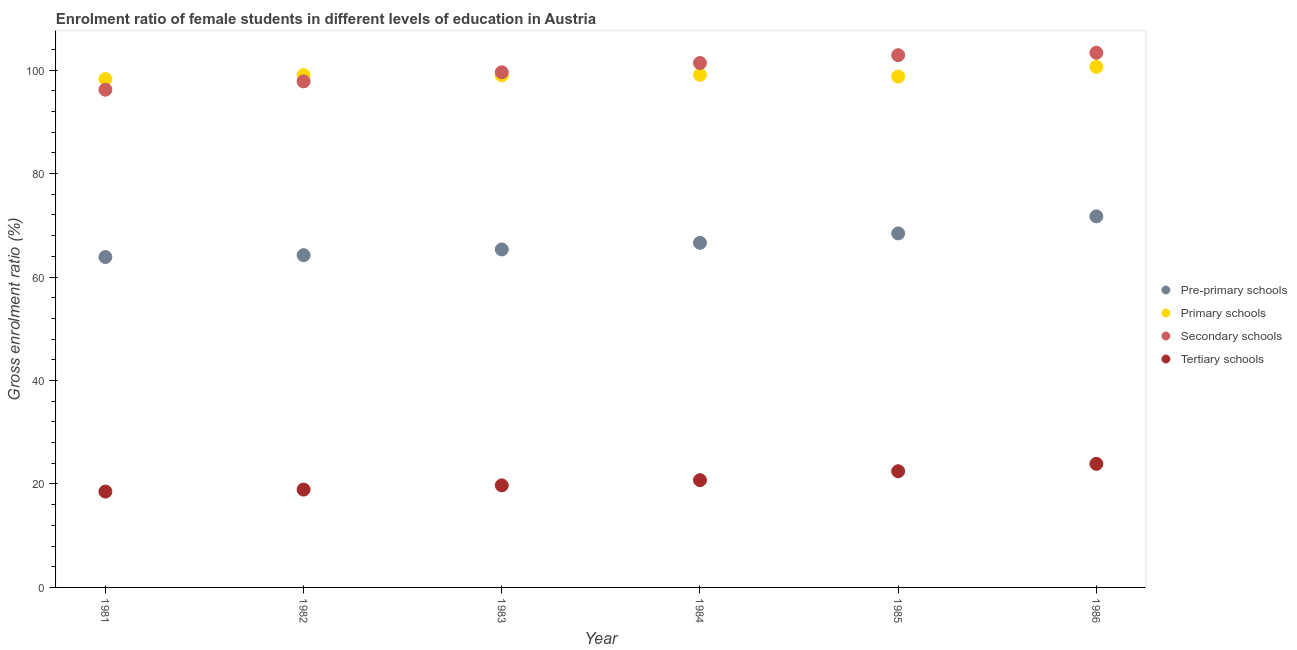Is the number of dotlines equal to the number of legend labels?
Keep it short and to the point. Yes. What is the gross enrolment ratio(male) in secondary schools in 1985?
Your answer should be very brief. 102.88. Across all years, what is the maximum gross enrolment ratio(male) in tertiary schools?
Offer a very short reply. 23.89. Across all years, what is the minimum gross enrolment ratio(male) in secondary schools?
Offer a very short reply. 96.21. What is the total gross enrolment ratio(male) in tertiary schools in the graph?
Make the answer very short. 124.24. What is the difference between the gross enrolment ratio(male) in pre-primary schools in 1985 and that in 1986?
Provide a short and direct response. -3.29. What is the difference between the gross enrolment ratio(male) in primary schools in 1985 and the gross enrolment ratio(male) in pre-primary schools in 1986?
Offer a very short reply. 27.02. What is the average gross enrolment ratio(male) in secondary schools per year?
Your response must be concise. 100.2. In the year 1986, what is the difference between the gross enrolment ratio(male) in tertiary schools and gross enrolment ratio(male) in primary schools?
Offer a very short reply. -76.74. In how many years, is the gross enrolment ratio(male) in pre-primary schools greater than 68 %?
Provide a short and direct response. 2. What is the ratio of the gross enrolment ratio(male) in tertiary schools in 1984 to that in 1985?
Offer a terse response. 0.92. Is the gross enrolment ratio(male) in pre-primary schools in 1982 less than that in 1983?
Your answer should be very brief. Yes. Is the difference between the gross enrolment ratio(male) in secondary schools in 1981 and 1983 greater than the difference between the gross enrolment ratio(male) in primary schools in 1981 and 1983?
Keep it short and to the point. No. What is the difference between the highest and the second highest gross enrolment ratio(male) in primary schools?
Provide a succinct answer. 1.54. What is the difference between the highest and the lowest gross enrolment ratio(male) in pre-primary schools?
Keep it short and to the point. 7.86. In how many years, is the gross enrolment ratio(male) in pre-primary schools greater than the average gross enrolment ratio(male) in pre-primary schools taken over all years?
Offer a terse response. 2. Is it the case that in every year, the sum of the gross enrolment ratio(male) in secondary schools and gross enrolment ratio(male) in primary schools is greater than the sum of gross enrolment ratio(male) in tertiary schools and gross enrolment ratio(male) in pre-primary schools?
Offer a terse response. No. Is it the case that in every year, the sum of the gross enrolment ratio(male) in pre-primary schools and gross enrolment ratio(male) in primary schools is greater than the gross enrolment ratio(male) in secondary schools?
Your answer should be compact. Yes. Is the gross enrolment ratio(male) in primary schools strictly greater than the gross enrolment ratio(male) in pre-primary schools over the years?
Provide a succinct answer. Yes. Does the graph contain any zero values?
Ensure brevity in your answer.  No. Does the graph contain grids?
Your response must be concise. No. How many legend labels are there?
Provide a succinct answer. 4. How are the legend labels stacked?
Offer a terse response. Vertical. What is the title of the graph?
Your answer should be very brief. Enrolment ratio of female students in different levels of education in Austria. What is the label or title of the X-axis?
Give a very brief answer. Year. What is the label or title of the Y-axis?
Your answer should be very brief. Gross enrolment ratio (%). What is the Gross enrolment ratio (%) in Pre-primary schools in 1981?
Keep it short and to the point. 63.86. What is the Gross enrolment ratio (%) in Primary schools in 1981?
Ensure brevity in your answer.  98.27. What is the Gross enrolment ratio (%) of Secondary schools in 1981?
Make the answer very short. 96.21. What is the Gross enrolment ratio (%) in Tertiary schools in 1981?
Your answer should be very brief. 18.53. What is the Gross enrolment ratio (%) in Pre-primary schools in 1982?
Keep it short and to the point. 64.22. What is the Gross enrolment ratio (%) in Primary schools in 1982?
Your response must be concise. 99.04. What is the Gross enrolment ratio (%) in Secondary schools in 1982?
Your answer should be compact. 97.81. What is the Gross enrolment ratio (%) of Tertiary schools in 1982?
Give a very brief answer. 18.91. What is the Gross enrolment ratio (%) in Pre-primary schools in 1983?
Your answer should be compact. 65.33. What is the Gross enrolment ratio (%) of Primary schools in 1983?
Offer a terse response. 98.97. What is the Gross enrolment ratio (%) of Secondary schools in 1983?
Make the answer very short. 99.58. What is the Gross enrolment ratio (%) in Tertiary schools in 1983?
Offer a very short reply. 19.73. What is the Gross enrolment ratio (%) in Pre-primary schools in 1984?
Offer a very short reply. 66.61. What is the Gross enrolment ratio (%) in Primary schools in 1984?
Offer a terse response. 99.09. What is the Gross enrolment ratio (%) of Secondary schools in 1984?
Provide a succinct answer. 101.37. What is the Gross enrolment ratio (%) of Tertiary schools in 1984?
Your response must be concise. 20.73. What is the Gross enrolment ratio (%) in Pre-primary schools in 1985?
Offer a very short reply. 68.43. What is the Gross enrolment ratio (%) of Primary schools in 1985?
Keep it short and to the point. 98.75. What is the Gross enrolment ratio (%) of Secondary schools in 1985?
Provide a short and direct response. 102.88. What is the Gross enrolment ratio (%) of Tertiary schools in 1985?
Ensure brevity in your answer.  22.46. What is the Gross enrolment ratio (%) in Pre-primary schools in 1986?
Make the answer very short. 71.72. What is the Gross enrolment ratio (%) of Primary schools in 1986?
Ensure brevity in your answer.  100.63. What is the Gross enrolment ratio (%) in Secondary schools in 1986?
Keep it short and to the point. 103.35. What is the Gross enrolment ratio (%) in Tertiary schools in 1986?
Keep it short and to the point. 23.89. Across all years, what is the maximum Gross enrolment ratio (%) of Pre-primary schools?
Ensure brevity in your answer.  71.72. Across all years, what is the maximum Gross enrolment ratio (%) of Primary schools?
Give a very brief answer. 100.63. Across all years, what is the maximum Gross enrolment ratio (%) in Secondary schools?
Make the answer very short. 103.35. Across all years, what is the maximum Gross enrolment ratio (%) of Tertiary schools?
Keep it short and to the point. 23.89. Across all years, what is the minimum Gross enrolment ratio (%) in Pre-primary schools?
Your answer should be very brief. 63.86. Across all years, what is the minimum Gross enrolment ratio (%) in Primary schools?
Offer a very short reply. 98.27. Across all years, what is the minimum Gross enrolment ratio (%) of Secondary schools?
Make the answer very short. 96.21. Across all years, what is the minimum Gross enrolment ratio (%) in Tertiary schools?
Offer a very short reply. 18.53. What is the total Gross enrolment ratio (%) in Pre-primary schools in the graph?
Give a very brief answer. 400.18. What is the total Gross enrolment ratio (%) in Primary schools in the graph?
Your response must be concise. 594.75. What is the total Gross enrolment ratio (%) in Secondary schools in the graph?
Offer a very short reply. 601.2. What is the total Gross enrolment ratio (%) of Tertiary schools in the graph?
Offer a very short reply. 124.24. What is the difference between the Gross enrolment ratio (%) in Pre-primary schools in 1981 and that in 1982?
Offer a terse response. -0.36. What is the difference between the Gross enrolment ratio (%) of Primary schools in 1981 and that in 1982?
Make the answer very short. -0.77. What is the difference between the Gross enrolment ratio (%) of Secondary schools in 1981 and that in 1982?
Give a very brief answer. -1.6. What is the difference between the Gross enrolment ratio (%) of Tertiary schools in 1981 and that in 1982?
Provide a short and direct response. -0.38. What is the difference between the Gross enrolment ratio (%) of Pre-primary schools in 1981 and that in 1983?
Ensure brevity in your answer.  -1.47. What is the difference between the Gross enrolment ratio (%) in Primary schools in 1981 and that in 1983?
Provide a succinct answer. -0.7. What is the difference between the Gross enrolment ratio (%) in Secondary schools in 1981 and that in 1983?
Give a very brief answer. -3.37. What is the difference between the Gross enrolment ratio (%) of Tertiary schools in 1981 and that in 1983?
Offer a very short reply. -1.2. What is the difference between the Gross enrolment ratio (%) in Pre-primary schools in 1981 and that in 1984?
Provide a succinct answer. -2.75. What is the difference between the Gross enrolment ratio (%) in Primary schools in 1981 and that in 1984?
Offer a terse response. -0.82. What is the difference between the Gross enrolment ratio (%) of Secondary schools in 1981 and that in 1984?
Give a very brief answer. -5.15. What is the difference between the Gross enrolment ratio (%) of Tertiary schools in 1981 and that in 1984?
Your response must be concise. -2.21. What is the difference between the Gross enrolment ratio (%) in Pre-primary schools in 1981 and that in 1985?
Offer a terse response. -4.57. What is the difference between the Gross enrolment ratio (%) in Primary schools in 1981 and that in 1985?
Provide a short and direct response. -0.48. What is the difference between the Gross enrolment ratio (%) in Secondary schools in 1981 and that in 1985?
Keep it short and to the point. -6.67. What is the difference between the Gross enrolment ratio (%) in Tertiary schools in 1981 and that in 1985?
Offer a terse response. -3.93. What is the difference between the Gross enrolment ratio (%) of Pre-primary schools in 1981 and that in 1986?
Keep it short and to the point. -7.86. What is the difference between the Gross enrolment ratio (%) in Primary schools in 1981 and that in 1986?
Give a very brief answer. -2.36. What is the difference between the Gross enrolment ratio (%) of Secondary schools in 1981 and that in 1986?
Your response must be concise. -7.13. What is the difference between the Gross enrolment ratio (%) in Tertiary schools in 1981 and that in 1986?
Ensure brevity in your answer.  -5.36. What is the difference between the Gross enrolment ratio (%) in Pre-primary schools in 1982 and that in 1983?
Ensure brevity in your answer.  -1.11. What is the difference between the Gross enrolment ratio (%) of Primary schools in 1982 and that in 1983?
Provide a short and direct response. 0.07. What is the difference between the Gross enrolment ratio (%) of Secondary schools in 1982 and that in 1983?
Provide a short and direct response. -1.76. What is the difference between the Gross enrolment ratio (%) in Tertiary schools in 1982 and that in 1983?
Your response must be concise. -0.82. What is the difference between the Gross enrolment ratio (%) of Pre-primary schools in 1982 and that in 1984?
Keep it short and to the point. -2.39. What is the difference between the Gross enrolment ratio (%) in Primary schools in 1982 and that in 1984?
Provide a short and direct response. -0.05. What is the difference between the Gross enrolment ratio (%) in Secondary schools in 1982 and that in 1984?
Make the answer very short. -3.55. What is the difference between the Gross enrolment ratio (%) in Tertiary schools in 1982 and that in 1984?
Your answer should be very brief. -1.82. What is the difference between the Gross enrolment ratio (%) in Pre-primary schools in 1982 and that in 1985?
Keep it short and to the point. -4.21. What is the difference between the Gross enrolment ratio (%) of Primary schools in 1982 and that in 1985?
Provide a short and direct response. 0.3. What is the difference between the Gross enrolment ratio (%) in Secondary schools in 1982 and that in 1985?
Offer a terse response. -5.07. What is the difference between the Gross enrolment ratio (%) in Tertiary schools in 1982 and that in 1985?
Offer a terse response. -3.55. What is the difference between the Gross enrolment ratio (%) in Pre-primary schools in 1982 and that in 1986?
Your response must be concise. -7.5. What is the difference between the Gross enrolment ratio (%) in Primary schools in 1982 and that in 1986?
Make the answer very short. -1.59. What is the difference between the Gross enrolment ratio (%) in Secondary schools in 1982 and that in 1986?
Provide a short and direct response. -5.53. What is the difference between the Gross enrolment ratio (%) of Tertiary schools in 1982 and that in 1986?
Offer a very short reply. -4.98. What is the difference between the Gross enrolment ratio (%) in Pre-primary schools in 1983 and that in 1984?
Your response must be concise. -1.28. What is the difference between the Gross enrolment ratio (%) in Primary schools in 1983 and that in 1984?
Provide a short and direct response. -0.12. What is the difference between the Gross enrolment ratio (%) of Secondary schools in 1983 and that in 1984?
Keep it short and to the point. -1.79. What is the difference between the Gross enrolment ratio (%) of Tertiary schools in 1983 and that in 1984?
Offer a terse response. -1.01. What is the difference between the Gross enrolment ratio (%) of Pre-primary schools in 1983 and that in 1985?
Ensure brevity in your answer.  -3.1. What is the difference between the Gross enrolment ratio (%) of Primary schools in 1983 and that in 1985?
Your response must be concise. 0.22. What is the difference between the Gross enrolment ratio (%) in Secondary schools in 1983 and that in 1985?
Your response must be concise. -3.3. What is the difference between the Gross enrolment ratio (%) in Tertiary schools in 1983 and that in 1985?
Offer a very short reply. -2.73. What is the difference between the Gross enrolment ratio (%) of Pre-primary schools in 1983 and that in 1986?
Your answer should be compact. -6.39. What is the difference between the Gross enrolment ratio (%) of Primary schools in 1983 and that in 1986?
Your answer should be compact. -1.66. What is the difference between the Gross enrolment ratio (%) in Secondary schools in 1983 and that in 1986?
Offer a terse response. -3.77. What is the difference between the Gross enrolment ratio (%) of Tertiary schools in 1983 and that in 1986?
Give a very brief answer. -4.16. What is the difference between the Gross enrolment ratio (%) in Pre-primary schools in 1984 and that in 1985?
Your response must be concise. -1.82. What is the difference between the Gross enrolment ratio (%) of Primary schools in 1984 and that in 1985?
Your response must be concise. 0.34. What is the difference between the Gross enrolment ratio (%) of Secondary schools in 1984 and that in 1985?
Offer a terse response. -1.52. What is the difference between the Gross enrolment ratio (%) of Tertiary schools in 1984 and that in 1985?
Keep it short and to the point. -1.72. What is the difference between the Gross enrolment ratio (%) of Pre-primary schools in 1984 and that in 1986?
Ensure brevity in your answer.  -5.11. What is the difference between the Gross enrolment ratio (%) of Primary schools in 1984 and that in 1986?
Make the answer very short. -1.54. What is the difference between the Gross enrolment ratio (%) of Secondary schools in 1984 and that in 1986?
Make the answer very short. -1.98. What is the difference between the Gross enrolment ratio (%) in Tertiary schools in 1984 and that in 1986?
Your answer should be very brief. -3.15. What is the difference between the Gross enrolment ratio (%) in Pre-primary schools in 1985 and that in 1986?
Give a very brief answer. -3.29. What is the difference between the Gross enrolment ratio (%) of Primary schools in 1985 and that in 1986?
Provide a succinct answer. -1.88. What is the difference between the Gross enrolment ratio (%) of Secondary schools in 1985 and that in 1986?
Offer a terse response. -0.46. What is the difference between the Gross enrolment ratio (%) of Tertiary schools in 1985 and that in 1986?
Your answer should be compact. -1.43. What is the difference between the Gross enrolment ratio (%) of Pre-primary schools in 1981 and the Gross enrolment ratio (%) of Primary schools in 1982?
Your response must be concise. -35.18. What is the difference between the Gross enrolment ratio (%) of Pre-primary schools in 1981 and the Gross enrolment ratio (%) of Secondary schools in 1982?
Your answer should be very brief. -33.95. What is the difference between the Gross enrolment ratio (%) of Pre-primary schools in 1981 and the Gross enrolment ratio (%) of Tertiary schools in 1982?
Provide a succinct answer. 44.95. What is the difference between the Gross enrolment ratio (%) in Primary schools in 1981 and the Gross enrolment ratio (%) in Secondary schools in 1982?
Offer a terse response. 0.46. What is the difference between the Gross enrolment ratio (%) of Primary schools in 1981 and the Gross enrolment ratio (%) of Tertiary schools in 1982?
Offer a terse response. 79.36. What is the difference between the Gross enrolment ratio (%) in Secondary schools in 1981 and the Gross enrolment ratio (%) in Tertiary schools in 1982?
Provide a short and direct response. 77.3. What is the difference between the Gross enrolment ratio (%) of Pre-primary schools in 1981 and the Gross enrolment ratio (%) of Primary schools in 1983?
Your response must be concise. -35.11. What is the difference between the Gross enrolment ratio (%) of Pre-primary schools in 1981 and the Gross enrolment ratio (%) of Secondary schools in 1983?
Give a very brief answer. -35.71. What is the difference between the Gross enrolment ratio (%) in Pre-primary schools in 1981 and the Gross enrolment ratio (%) in Tertiary schools in 1983?
Provide a succinct answer. 44.14. What is the difference between the Gross enrolment ratio (%) in Primary schools in 1981 and the Gross enrolment ratio (%) in Secondary schools in 1983?
Provide a short and direct response. -1.31. What is the difference between the Gross enrolment ratio (%) of Primary schools in 1981 and the Gross enrolment ratio (%) of Tertiary schools in 1983?
Keep it short and to the point. 78.54. What is the difference between the Gross enrolment ratio (%) of Secondary schools in 1981 and the Gross enrolment ratio (%) of Tertiary schools in 1983?
Offer a terse response. 76.49. What is the difference between the Gross enrolment ratio (%) of Pre-primary schools in 1981 and the Gross enrolment ratio (%) of Primary schools in 1984?
Provide a short and direct response. -35.22. What is the difference between the Gross enrolment ratio (%) of Pre-primary schools in 1981 and the Gross enrolment ratio (%) of Secondary schools in 1984?
Ensure brevity in your answer.  -37.5. What is the difference between the Gross enrolment ratio (%) of Pre-primary schools in 1981 and the Gross enrolment ratio (%) of Tertiary schools in 1984?
Your response must be concise. 43.13. What is the difference between the Gross enrolment ratio (%) in Primary schools in 1981 and the Gross enrolment ratio (%) in Secondary schools in 1984?
Make the answer very short. -3.1. What is the difference between the Gross enrolment ratio (%) in Primary schools in 1981 and the Gross enrolment ratio (%) in Tertiary schools in 1984?
Your answer should be very brief. 77.54. What is the difference between the Gross enrolment ratio (%) in Secondary schools in 1981 and the Gross enrolment ratio (%) in Tertiary schools in 1984?
Keep it short and to the point. 75.48. What is the difference between the Gross enrolment ratio (%) of Pre-primary schools in 1981 and the Gross enrolment ratio (%) of Primary schools in 1985?
Make the answer very short. -34.88. What is the difference between the Gross enrolment ratio (%) of Pre-primary schools in 1981 and the Gross enrolment ratio (%) of Secondary schools in 1985?
Provide a short and direct response. -39.02. What is the difference between the Gross enrolment ratio (%) in Pre-primary schools in 1981 and the Gross enrolment ratio (%) in Tertiary schools in 1985?
Give a very brief answer. 41.41. What is the difference between the Gross enrolment ratio (%) in Primary schools in 1981 and the Gross enrolment ratio (%) in Secondary schools in 1985?
Your answer should be very brief. -4.61. What is the difference between the Gross enrolment ratio (%) in Primary schools in 1981 and the Gross enrolment ratio (%) in Tertiary schools in 1985?
Offer a terse response. 75.81. What is the difference between the Gross enrolment ratio (%) in Secondary schools in 1981 and the Gross enrolment ratio (%) in Tertiary schools in 1985?
Offer a very short reply. 73.76. What is the difference between the Gross enrolment ratio (%) in Pre-primary schools in 1981 and the Gross enrolment ratio (%) in Primary schools in 1986?
Offer a very short reply. -36.76. What is the difference between the Gross enrolment ratio (%) of Pre-primary schools in 1981 and the Gross enrolment ratio (%) of Secondary schools in 1986?
Give a very brief answer. -39.48. What is the difference between the Gross enrolment ratio (%) of Pre-primary schools in 1981 and the Gross enrolment ratio (%) of Tertiary schools in 1986?
Give a very brief answer. 39.98. What is the difference between the Gross enrolment ratio (%) of Primary schools in 1981 and the Gross enrolment ratio (%) of Secondary schools in 1986?
Ensure brevity in your answer.  -5.08. What is the difference between the Gross enrolment ratio (%) in Primary schools in 1981 and the Gross enrolment ratio (%) in Tertiary schools in 1986?
Offer a terse response. 74.38. What is the difference between the Gross enrolment ratio (%) in Secondary schools in 1981 and the Gross enrolment ratio (%) in Tertiary schools in 1986?
Offer a very short reply. 72.32. What is the difference between the Gross enrolment ratio (%) in Pre-primary schools in 1982 and the Gross enrolment ratio (%) in Primary schools in 1983?
Your answer should be compact. -34.75. What is the difference between the Gross enrolment ratio (%) in Pre-primary schools in 1982 and the Gross enrolment ratio (%) in Secondary schools in 1983?
Your answer should be compact. -35.36. What is the difference between the Gross enrolment ratio (%) of Pre-primary schools in 1982 and the Gross enrolment ratio (%) of Tertiary schools in 1983?
Provide a succinct answer. 44.5. What is the difference between the Gross enrolment ratio (%) in Primary schools in 1982 and the Gross enrolment ratio (%) in Secondary schools in 1983?
Ensure brevity in your answer.  -0.54. What is the difference between the Gross enrolment ratio (%) in Primary schools in 1982 and the Gross enrolment ratio (%) in Tertiary schools in 1983?
Provide a short and direct response. 79.32. What is the difference between the Gross enrolment ratio (%) of Secondary schools in 1982 and the Gross enrolment ratio (%) of Tertiary schools in 1983?
Your answer should be compact. 78.09. What is the difference between the Gross enrolment ratio (%) of Pre-primary schools in 1982 and the Gross enrolment ratio (%) of Primary schools in 1984?
Offer a terse response. -34.86. What is the difference between the Gross enrolment ratio (%) in Pre-primary schools in 1982 and the Gross enrolment ratio (%) in Secondary schools in 1984?
Offer a very short reply. -37.14. What is the difference between the Gross enrolment ratio (%) of Pre-primary schools in 1982 and the Gross enrolment ratio (%) of Tertiary schools in 1984?
Your answer should be compact. 43.49. What is the difference between the Gross enrolment ratio (%) of Primary schools in 1982 and the Gross enrolment ratio (%) of Secondary schools in 1984?
Keep it short and to the point. -2.32. What is the difference between the Gross enrolment ratio (%) of Primary schools in 1982 and the Gross enrolment ratio (%) of Tertiary schools in 1984?
Make the answer very short. 78.31. What is the difference between the Gross enrolment ratio (%) in Secondary schools in 1982 and the Gross enrolment ratio (%) in Tertiary schools in 1984?
Offer a very short reply. 77.08. What is the difference between the Gross enrolment ratio (%) of Pre-primary schools in 1982 and the Gross enrolment ratio (%) of Primary schools in 1985?
Your answer should be very brief. -34.52. What is the difference between the Gross enrolment ratio (%) in Pre-primary schools in 1982 and the Gross enrolment ratio (%) in Secondary schools in 1985?
Offer a very short reply. -38.66. What is the difference between the Gross enrolment ratio (%) in Pre-primary schools in 1982 and the Gross enrolment ratio (%) in Tertiary schools in 1985?
Give a very brief answer. 41.77. What is the difference between the Gross enrolment ratio (%) of Primary schools in 1982 and the Gross enrolment ratio (%) of Secondary schools in 1985?
Offer a very short reply. -3.84. What is the difference between the Gross enrolment ratio (%) in Primary schools in 1982 and the Gross enrolment ratio (%) in Tertiary schools in 1985?
Ensure brevity in your answer.  76.58. What is the difference between the Gross enrolment ratio (%) in Secondary schools in 1982 and the Gross enrolment ratio (%) in Tertiary schools in 1985?
Your answer should be compact. 75.36. What is the difference between the Gross enrolment ratio (%) in Pre-primary schools in 1982 and the Gross enrolment ratio (%) in Primary schools in 1986?
Ensure brevity in your answer.  -36.41. What is the difference between the Gross enrolment ratio (%) in Pre-primary schools in 1982 and the Gross enrolment ratio (%) in Secondary schools in 1986?
Offer a terse response. -39.12. What is the difference between the Gross enrolment ratio (%) of Pre-primary schools in 1982 and the Gross enrolment ratio (%) of Tertiary schools in 1986?
Keep it short and to the point. 40.33. What is the difference between the Gross enrolment ratio (%) of Primary schools in 1982 and the Gross enrolment ratio (%) of Secondary schools in 1986?
Offer a terse response. -4.3. What is the difference between the Gross enrolment ratio (%) of Primary schools in 1982 and the Gross enrolment ratio (%) of Tertiary schools in 1986?
Your response must be concise. 75.15. What is the difference between the Gross enrolment ratio (%) of Secondary schools in 1982 and the Gross enrolment ratio (%) of Tertiary schools in 1986?
Your response must be concise. 73.93. What is the difference between the Gross enrolment ratio (%) of Pre-primary schools in 1983 and the Gross enrolment ratio (%) of Primary schools in 1984?
Offer a terse response. -33.76. What is the difference between the Gross enrolment ratio (%) of Pre-primary schools in 1983 and the Gross enrolment ratio (%) of Secondary schools in 1984?
Give a very brief answer. -36.04. What is the difference between the Gross enrolment ratio (%) in Pre-primary schools in 1983 and the Gross enrolment ratio (%) in Tertiary schools in 1984?
Offer a very short reply. 44.6. What is the difference between the Gross enrolment ratio (%) in Primary schools in 1983 and the Gross enrolment ratio (%) in Secondary schools in 1984?
Provide a succinct answer. -2.4. What is the difference between the Gross enrolment ratio (%) in Primary schools in 1983 and the Gross enrolment ratio (%) in Tertiary schools in 1984?
Your answer should be very brief. 78.24. What is the difference between the Gross enrolment ratio (%) in Secondary schools in 1983 and the Gross enrolment ratio (%) in Tertiary schools in 1984?
Give a very brief answer. 78.85. What is the difference between the Gross enrolment ratio (%) in Pre-primary schools in 1983 and the Gross enrolment ratio (%) in Primary schools in 1985?
Keep it short and to the point. -33.42. What is the difference between the Gross enrolment ratio (%) of Pre-primary schools in 1983 and the Gross enrolment ratio (%) of Secondary schools in 1985?
Give a very brief answer. -37.55. What is the difference between the Gross enrolment ratio (%) in Pre-primary schools in 1983 and the Gross enrolment ratio (%) in Tertiary schools in 1985?
Make the answer very short. 42.87. What is the difference between the Gross enrolment ratio (%) of Primary schools in 1983 and the Gross enrolment ratio (%) of Secondary schools in 1985?
Your answer should be compact. -3.91. What is the difference between the Gross enrolment ratio (%) of Primary schools in 1983 and the Gross enrolment ratio (%) of Tertiary schools in 1985?
Your response must be concise. 76.51. What is the difference between the Gross enrolment ratio (%) of Secondary schools in 1983 and the Gross enrolment ratio (%) of Tertiary schools in 1985?
Offer a very short reply. 77.12. What is the difference between the Gross enrolment ratio (%) of Pre-primary schools in 1983 and the Gross enrolment ratio (%) of Primary schools in 1986?
Offer a terse response. -35.3. What is the difference between the Gross enrolment ratio (%) of Pre-primary schools in 1983 and the Gross enrolment ratio (%) of Secondary schools in 1986?
Your answer should be compact. -38.02. What is the difference between the Gross enrolment ratio (%) in Pre-primary schools in 1983 and the Gross enrolment ratio (%) in Tertiary schools in 1986?
Give a very brief answer. 41.44. What is the difference between the Gross enrolment ratio (%) of Primary schools in 1983 and the Gross enrolment ratio (%) of Secondary schools in 1986?
Ensure brevity in your answer.  -4.38. What is the difference between the Gross enrolment ratio (%) in Primary schools in 1983 and the Gross enrolment ratio (%) in Tertiary schools in 1986?
Offer a very short reply. 75.08. What is the difference between the Gross enrolment ratio (%) in Secondary schools in 1983 and the Gross enrolment ratio (%) in Tertiary schools in 1986?
Offer a terse response. 75.69. What is the difference between the Gross enrolment ratio (%) in Pre-primary schools in 1984 and the Gross enrolment ratio (%) in Primary schools in 1985?
Keep it short and to the point. -32.13. What is the difference between the Gross enrolment ratio (%) of Pre-primary schools in 1984 and the Gross enrolment ratio (%) of Secondary schools in 1985?
Ensure brevity in your answer.  -36.27. What is the difference between the Gross enrolment ratio (%) in Pre-primary schools in 1984 and the Gross enrolment ratio (%) in Tertiary schools in 1985?
Your answer should be very brief. 44.16. What is the difference between the Gross enrolment ratio (%) in Primary schools in 1984 and the Gross enrolment ratio (%) in Secondary schools in 1985?
Your response must be concise. -3.79. What is the difference between the Gross enrolment ratio (%) in Primary schools in 1984 and the Gross enrolment ratio (%) in Tertiary schools in 1985?
Keep it short and to the point. 76.63. What is the difference between the Gross enrolment ratio (%) in Secondary schools in 1984 and the Gross enrolment ratio (%) in Tertiary schools in 1985?
Give a very brief answer. 78.91. What is the difference between the Gross enrolment ratio (%) in Pre-primary schools in 1984 and the Gross enrolment ratio (%) in Primary schools in 1986?
Make the answer very short. -34.01. What is the difference between the Gross enrolment ratio (%) in Pre-primary schools in 1984 and the Gross enrolment ratio (%) in Secondary schools in 1986?
Give a very brief answer. -36.73. What is the difference between the Gross enrolment ratio (%) of Pre-primary schools in 1984 and the Gross enrolment ratio (%) of Tertiary schools in 1986?
Ensure brevity in your answer.  42.73. What is the difference between the Gross enrolment ratio (%) in Primary schools in 1984 and the Gross enrolment ratio (%) in Secondary schools in 1986?
Ensure brevity in your answer.  -4.26. What is the difference between the Gross enrolment ratio (%) of Primary schools in 1984 and the Gross enrolment ratio (%) of Tertiary schools in 1986?
Your answer should be very brief. 75.2. What is the difference between the Gross enrolment ratio (%) in Secondary schools in 1984 and the Gross enrolment ratio (%) in Tertiary schools in 1986?
Give a very brief answer. 77.48. What is the difference between the Gross enrolment ratio (%) of Pre-primary schools in 1985 and the Gross enrolment ratio (%) of Primary schools in 1986?
Offer a very short reply. -32.2. What is the difference between the Gross enrolment ratio (%) in Pre-primary schools in 1985 and the Gross enrolment ratio (%) in Secondary schools in 1986?
Keep it short and to the point. -34.92. What is the difference between the Gross enrolment ratio (%) of Pre-primary schools in 1985 and the Gross enrolment ratio (%) of Tertiary schools in 1986?
Give a very brief answer. 44.54. What is the difference between the Gross enrolment ratio (%) of Primary schools in 1985 and the Gross enrolment ratio (%) of Secondary schools in 1986?
Make the answer very short. -4.6. What is the difference between the Gross enrolment ratio (%) in Primary schools in 1985 and the Gross enrolment ratio (%) in Tertiary schools in 1986?
Provide a short and direct response. 74.86. What is the difference between the Gross enrolment ratio (%) of Secondary schools in 1985 and the Gross enrolment ratio (%) of Tertiary schools in 1986?
Provide a succinct answer. 78.99. What is the average Gross enrolment ratio (%) in Pre-primary schools per year?
Your response must be concise. 66.7. What is the average Gross enrolment ratio (%) in Primary schools per year?
Give a very brief answer. 99.12. What is the average Gross enrolment ratio (%) of Secondary schools per year?
Give a very brief answer. 100.2. What is the average Gross enrolment ratio (%) of Tertiary schools per year?
Give a very brief answer. 20.71. In the year 1981, what is the difference between the Gross enrolment ratio (%) of Pre-primary schools and Gross enrolment ratio (%) of Primary schools?
Your answer should be very brief. -34.41. In the year 1981, what is the difference between the Gross enrolment ratio (%) of Pre-primary schools and Gross enrolment ratio (%) of Secondary schools?
Your response must be concise. -32.35. In the year 1981, what is the difference between the Gross enrolment ratio (%) of Pre-primary schools and Gross enrolment ratio (%) of Tertiary schools?
Your answer should be compact. 45.34. In the year 1981, what is the difference between the Gross enrolment ratio (%) of Primary schools and Gross enrolment ratio (%) of Secondary schools?
Keep it short and to the point. 2.06. In the year 1981, what is the difference between the Gross enrolment ratio (%) of Primary schools and Gross enrolment ratio (%) of Tertiary schools?
Your answer should be compact. 79.75. In the year 1981, what is the difference between the Gross enrolment ratio (%) in Secondary schools and Gross enrolment ratio (%) in Tertiary schools?
Your answer should be compact. 77.69. In the year 1982, what is the difference between the Gross enrolment ratio (%) of Pre-primary schools and Gross enrolment ratio (%) of Primary schools?
Give a very brief answer. -34.82. In the year 1982, what is the difference between the Gross enrolment ratio (%) in Pre-primary schools and Gross enrolment ratio (%) in Secondary schools?
Keep it short and to the point. -33.59. In the year 1982, what is the difference between the Gross enrolment ratio (%) in Pre-primary schools and Gross enrolment ratio (%) in Tertiary schools?
Give a very brief answer. 45.31. In the year 1982, what is the difference between the Gross enrolment ratio (%) in Primary schools and Gross enrolment ratio (%) in Secondary schools?
Ensure brevity in your answer.  1.23. In the year 1982, what is the difference between the Gross enrolment ratio (%) in Primary schools and Gross enrolment ratio (%) in Tertiary schools?
Provide a short and direct response. 80.13. In the year 1982, what is the difference between the Gross enrolment ratio (%) of Secondary schools and Gross enrolment ratio (%) of Tertiary schools?
Make the answer very short. 78.9. In the year 1983, what is the difference between the Gross enrolment ratio (%) of Pre-primary schools and Gross enrolment ratio (%) of Primary schools?
Make the answer very short. -33.64. In the year 1983, what is the difference between the Gross enrolment ratio (%) of Pre-primary schools and Gross enrolment ratio (%) of Secondary schools?
Provide a short and direct response. -34.25. In the year 1983, what is the difference between the Gross enrolment ratio (%) in Pre-primary schools and Gross enrolment ratio (%) in Tertiary schools?
Make the answer very short. 45.6. In the year 1983, what is the difference between the Gross enrolment ratio (%) of Primary schools and Gross enrolment ratio (%) of Secondary schools?
Your response must be concise. -0.61. In the year 1983, what is the difference between the Gross enrolment ratio (%) of Primary schools and Gross enrolment ratio (%) of Tertiary schools?
Provide a succinct answer. 79.24. In the year 1983, what is the difference between the Gross enrolment ratio (%) of Secondary schools and Gross enrolment ratio (%) of Tertiary schools?
Ensure brevity in your answer.  79.85. In the year 1984, what is the difference between the Gross enrolment ratio (%) in Pre-primary schools and Gross enrolment ratio (%) in Primary schools?
Give a very brief answer. -32.47. In the year 1984, what is the difference between the Gross enrolment ratio (%) of Pre-primary schools and Gross enrolment ratio (%) of Secondary schools?
Your answer should be compact. -34.75. In the year 1984, what is the difference between the Gross enrolment ratio (%) in Pre-primary schools and Gross enrolment ratio (%) in Tertiary schools?
Your answer should be very brief. 45.88. In the year 1984, what is the difference between the Gross enrolment ratio (%) in Primary schools and Gross enrolment ratio (%) in Secondary schools?
Your answer should be compact. -2.28. In the year 1984, what is the difference between the Gross enrolment ratio (%) of Primary schools and Gross enrolment ratio (%) of Tertiary schools?
Your answer should be compact. 78.35. In the year 1984, what is the difference between the Gross enrolment ratio (%) in Secondary schools and Gross enrolment ratio (%) in Tertiary schools?
Offer a terse response. 80.63. In the year 1985, what is the difference between the Gross enrolment ratio (%) in Pre-primary schools and Gross enrolment ratio (%) in Primary schools?
Ensure brevity in your answer.  -30.32. In the year 1985, what is the difference between the Gross enrolment ratio (%) of Pre-primary schools and Gross enrolment ratio (%) of Secondary schools?
Ensure brevity in your answer.  -34.45. In the year 1985, what is the difference between the Gross enrolment ratio (%) in Pre-primary schools and Gross enrolment ratio (%) in Tertiary schools?
Your answer should be compact. 45.97. In the year 1985, what is the difference between the Gross enrolment ratio (%) in Primary schools and Gross enrolment ratio (%) in Secondary schools?
Make the answer very short. -4.14. In the year 1985, what is the difference between the Gross enrolment ratio (%) in Primary schools and Gross enrolment ratio (%) in Tertiary schools?
Your answer should be very brief. 76.29. In the year 1985, what is the difference between the Gross enrolment ratio (%) in Secondary schools and Gross enrolment ratio (%) in Tertiary schools?
Your answer should be compact. 80.42. In the year 1986, what is the difference between the Gross enrolment ratio (%) of Pre-primary schools and Gross enrolment ratio (%) of Primary schools?
Your answer should be compact. -28.9. In the year 1986, what is the difference between the Gross enrolment ratio (%) in Pre-primary schools and Gross enrolment ratio (%) in Secondary schools?
Provide a succinct answer. -31.62. In the year 1986, what is the difference between the Gross enrolment ratio (%) of Pre-primary schools and Gross enrolment ratio (%) of Tertiary schools?
Offer a terse response. 47.84. In the year 1986, what is the difference between the Gross enrolment ratio (%) in Primary schools and Gross enrolment ratio (%) in Secondary schools?
Ensure brevity in your answer.  -2.72. In the year 1986, what is the difference between the Gross enrolment ratio (%) of Primary schools and Gross enrolment ratio (%) of Tertiary schools?
Offer a very short reply. 76.74. In the year 1986, what is the difference between the Gross enrolment ratio (%) in Secondary schools and Gross enrolment ratio (%) in Tertiary schools?
Give a very brief answer. 79.46. What is the ratio of the Gross enrolment ratio (%) in Primary schools in 1981 to that in 1982?
Keep it short and to the point. 0.99. What is the ratio of the Gross enrolment ratio (%) in Secondary schools in 1981 to that in 1982?
Provide a succinct answer. 0.98. What is the ratio of the Gross enrolment ratio (%) of Tertiary schools in 1981 to that in 1982?
Offer a terse response. 0.98. What is the ratio of the Gross enrolment ratio (%) in Pre-primary schools in 1981 to that in 1983?
Offer a very short reply. 0.98. What is the ratio of the Gross enrolment ratio (%) of Primary schools in 1981 to that in 1983?
Offer a very short reply. 0.99. What is the ratio of the Gross enrolment ratio (%) of Secondary schools in 1981 to that in 1983?
Your response must be concise. 0.97. What is the ratio of the Gross enrolment ratio (%) in Tertiary schools in 1981 to that in 1983?
Make the answer very short. 0.94. What is the ratio of the Gross enrolment ratio (%) of Pre-primary schools in 1981 to that in 1984?
Provide a succinct answer. 0.96. What is the ratio of the Gross enrolment ratio (%) in Primary schools in 1981 to that in 1984?
Provide a succinct answer. 0.99. What is the ratio of the Gross enrolment ratio (%) of Secondary schools in 1981 to that in 1984?
Give a very brief answer. 0.95. What is the ratio of the Gross enrolment ratio (%) of Tertiary schools in 1981 to that in 1984?
Keep it short and to the point. 0.89. What is the ratio of the Gross enrolment ratio (%) of Secondary schools in 1981 to that in 1985?
Provide a short and direct response. 0.94. What is the ratio of the Gross enrolment ratio (%) of Tertiary schools in 1981 to that in 1985?
Offer a very short reply. 0.82. What is the ratio of the Gross enrolment ratio (%) of Pre-primary schools in 1981 to that in 1986?
Your answer should be compact. 0.89. What is the ratio of the Gross enrolment ratio (%) of Primary schools in 1981 to that in 1986?
Make the answer very short. 0.98. What is the ratio of the Gross enrolment ratio (%) in Secondary schools in 1981 to that in 1986?
Keep it short and to the point. 0.93. What is the ratio of the Gross enrolment ratio (%) of Tertiary schools in 1981 to that in 1986?
Offer a terse response. 0.78. What is the ratio of the Gross enrolment ratio (%) of Primary schools in 1982 to that in 1983?
Offer a very short reply. 1. What is the ratio of the Gross enrolment ratio (%) in Secondary schools in 1982 to that in 1983?
Offer a very short reply. 0.98. What is the ratio of the Gross enrolment ratio (%) in Tertiary schools in 1982 to that in 1983?
Your response must be concise. 0.96. What is the ratio of the Gross enrolment ratio (%) in Pre-primary schools in 1982 to that in 1984?
Provide a succinct answer. 0.96. What is the ratio of the Gross enrolment ratio (%) in Tertiary schools in 1982 to that in 1984?
Provide a short and direct response. 0.91. What is the ratio of the Gross enrolment ratio (%) of Pre-primary schools in 1982 to that in 1985?
Provide a succinct answer. 0.94. What is the ratio of the Gross enrolment ratio (%) in Secondary schools in 1982 to that in 1985?
Offer a very short reply. 0.95. What is the ratio of the Gross enrolment ratio (%) in Tertiary schools in 1982 to that in 1985?
Your response must be concise. 0.84. What is the ratio of the Gross enrolment ratio (%) of Pre-primary schools in 1982 to that in 1986?
Keep it short and to the point. 0.9. What is the ratio of the Gross enrolment ratio (%) of Primary schools in 1982 to that in 1986?
Your response must be concise. 0.98. What is the ratio of the Gross enrolment ratio (%) in Secondary schools in 1982 to that in 1986?
Ensure brevity in your answer.  0.95. What is the ratio of the Gross enrolment ratio (%) in Tertiary schools in 1982 to that in 1986?
Keep it short and to the point. 0.79. What is the ratio of the Gross enrolment ratio (%) of Pre-primary schools in 1983 to that in 1984?
Your answer should be compact. 0.98. What is the ratio of the Gross enrolment ratio (%) in Primary schools in 1983 to that in 1984?
Your response must be concise. 1. What is the ratio of the Gross enrolment ratio (%) of Secondary schools in 1983 to that in 1984?
Your answer should be very brief. 0.98. What is the ratio of the Gross enrolment ratio (%) in Tertiary schools in 1983 to that in 1984?
Make the answer very short. 0.95. What is the ratio of the Gross enrolment ratio (%) of Pre-primary schools in 1983 to that in 1985?
Give a very brief answer. 0.95. What is the ratio of the Gross enrolment ratio (%) of Secondary schools in 1983 to that in 1985?
Provide a succinct answer. 0.97. What is the ratio of the Gross enrolment ratio (%) of Tertiary schools in 1983 to that in 1985?
Provide a short and direct response. 0.88. What is the ratio of the Gross enrolment ratio (%) in Pre-primary schools in 1983 to that in 1986?
Provide a short and direct response. 0.91. What is the ratio of the Gross enrolment ratio (%) of Primary schools in 1983 to that in 1986?
Your answer should be very brief. 0.98. What is the ratio of the Gross enrolment ratio (%) of Secondary schools in 1983 to that in 1986?
Offer a terse response. 0.96. What is the ratio of the Gross enrolment ratio (%) in Tertiary schools in 1983 to that in 1986?
Your response must be concise. 0.83. What is the ratio of the Gross enrolment ratio (%) of Pre-primary schools in 1984 to that in 1985?
Provide a succinct answer. 0.97. What is the ratio of the Gross enrolment ratio (%) in Primary schools in 1984 to that in 1985?
Provide a succinct answer. 1. What is the ratio of the Gross enrolment ratio (%) in Tertiary schools in 1984 to that in 1985?
Your answer should be compact. 0.92. What is the ratio of the Gross enrolment ratio (%) of Pre-primary schools in 1984 to that in 1986?
Give a very brief answer. 0.93. What is the ratio of the Gross enrolment ratio (%) of Primary schools in 1984 to that in 1986?
Your answer should be compact. 0.98. What is the ratio of the Gross enrolment ratio (%) of Secondary schools in 1984 to that in 1986?
Make the answer very short. 0.98. What is the ratio of the Gross enrolment ratio (%) in Tertiary schools in 1984 to that in 1986?
Provide a short and direct response. 0.87. What is the ratio of the Gross enrolment ratio (%) in Pre-primary schools in 1985 to that in 1986?
Ensure brevity in your answer.  0.95. What is the ratio of the Gross enrolment ratio (%) of Primary schools in 1985 to that in 1986?
Provide a short and direct response. 0.98. What is the ratio of the Gross enrolment ratio (%) in Secondary schools in 1985 to that in 1986?
Your answer should be very brief. 1. What is the ratio of the Gross enrolment ratio (%) in Tertiary schools in 1985 to that in 1986?
Give a very brief answer. 0.94. What is the difference between the highest and the second highest Gross enrolment ratio (%) in Pre-primary schools?
Keep it short and to the point. 3.29. What is the difference between the highest and the second highest Gross enrolment ratio (%) of Primary schools?
Provide a succinct answer. 1.54. What is the difference between the highest and the second highest Gross enrolment ratio (%) in Secondary schools?
Keep it short and to the point. 0.46. What is the difference between the highest and the second highest Gross enrolment ratio (%) of Tertiary schools?
Ensure brevity in your answer.  1.43. What is the difference between the highest and the lowest Gross enrolment ratio (%) in Pre-primary schools?
Your answer should be very brief. 7.86. What is the difference between the highest and the lowest Gross enrolment ratio (%) in Primary schools?
Your answer should be very brief. 2.36. What is the difference between the highest and the lowest Gross enrolment ratio (%) in Secondary schools?
Offer a very short reply. 7.13. What is the difference between the highest and the lowest Gross enrolment ratio (%) of Tertiary schools?
Provide a succinct answer. 5.36. 